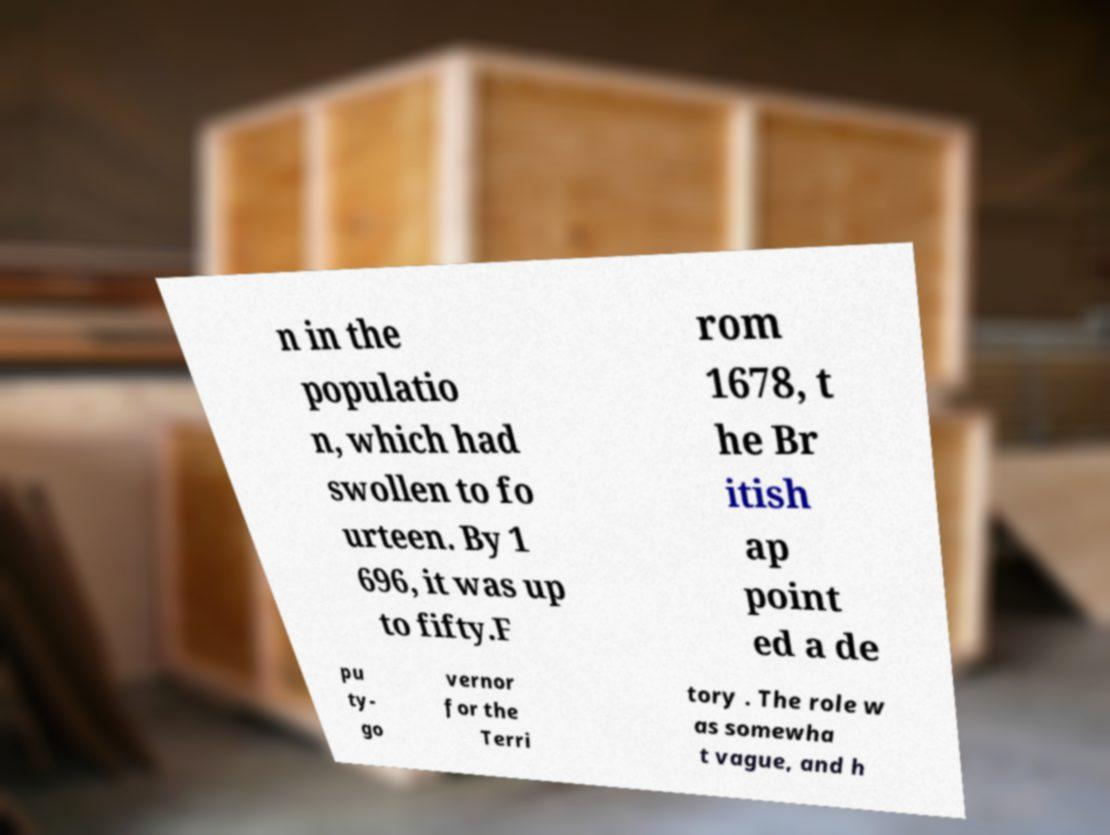What messages or text are displayed in this image? I need them in a readable, typed format. n in the populatio n, which had swollen to fo urteen. By 1 696, it was up to fifty.F rom 1678, t he Br itish ap point ed a de pu ty- go vernor for the Terri tory . The role w as somewha t vague, and h 